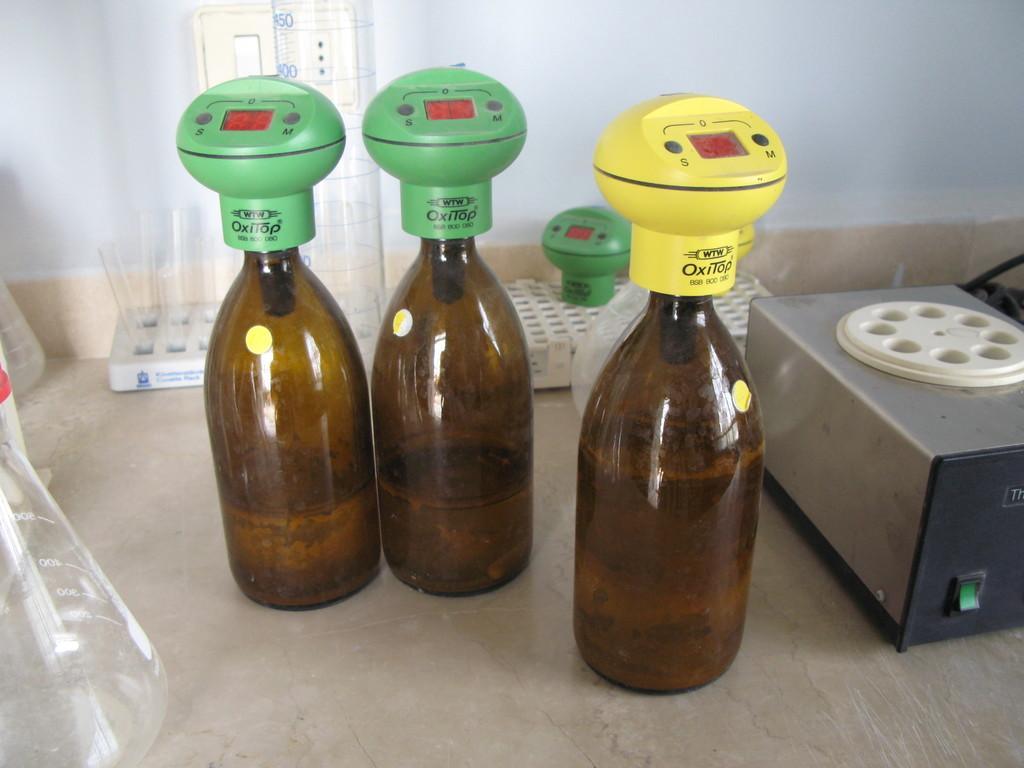Could you give a brief overview of what you see in this image? In this picture there are some bottles with some meters fixed on it and there are some test tubes behind it. 